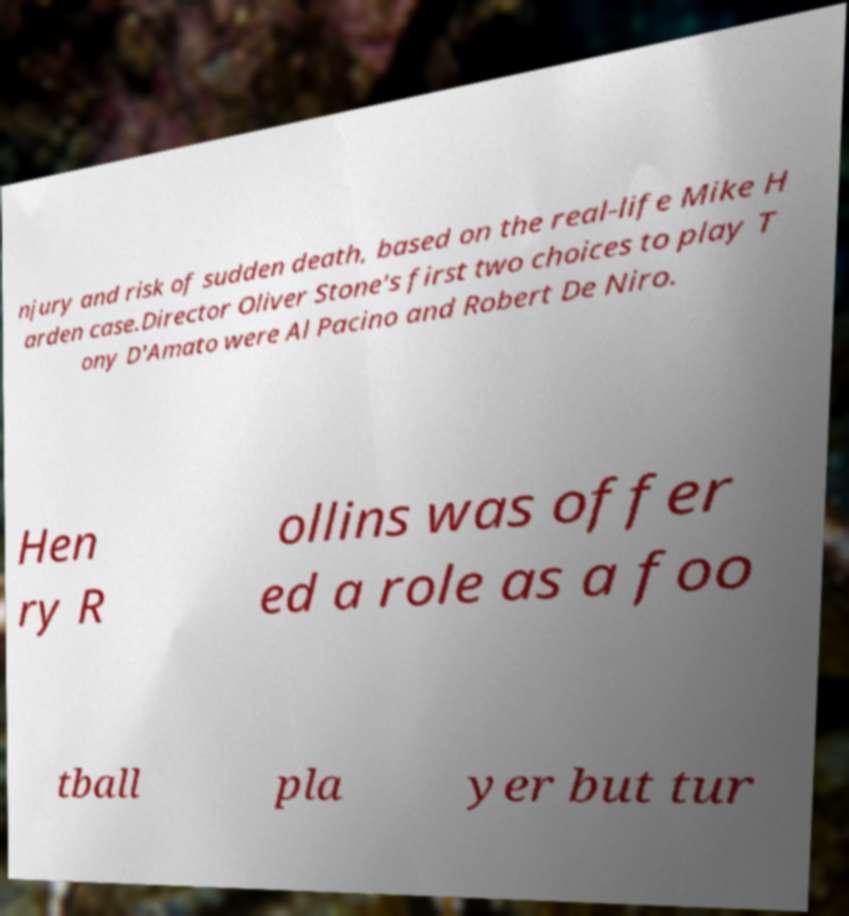Can you accurately transcribe the text from the provided image for me? njury and risk of sudden death, based on the real-life Mike H arden case.Director Oliver Stone's first two choices to play T ony D'Amato were Al Pacino and Robert De Niro. Hen ry R ollins was offer ed a role as a foo tball pla yer but tur 